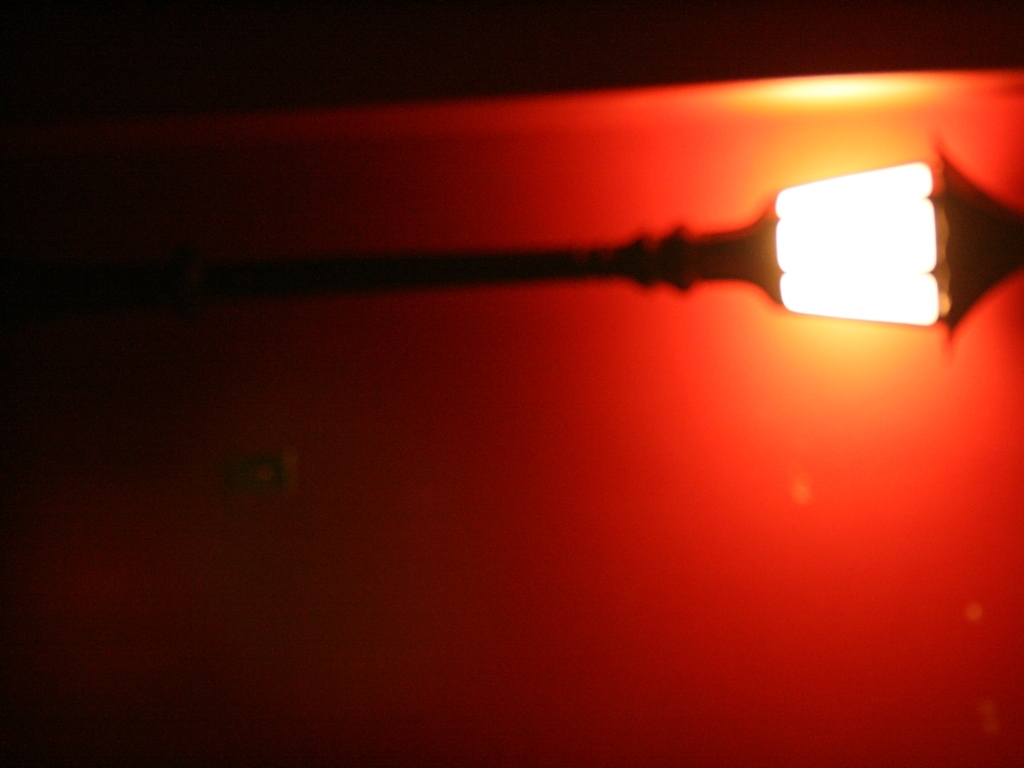Can you describe the mood or atmosphere of this image? The image emits a warm and mysterious ambiance. The predominant red hue and soft focus contribute to a somewhat eerie, secretive, or intimate mood. 